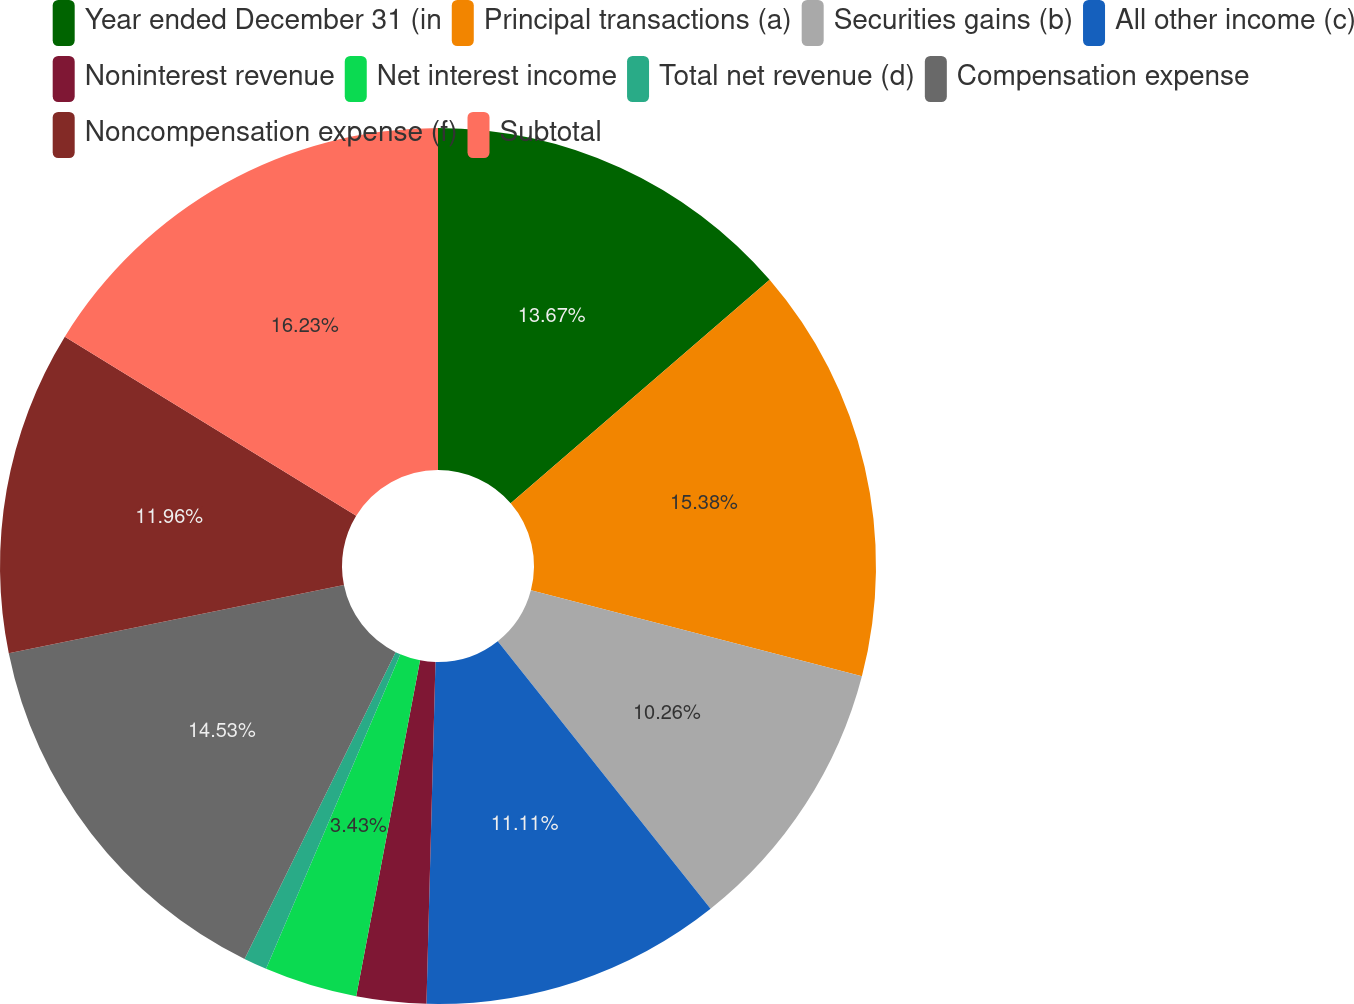Convert chart. <chart><loc_0><loc_0><loc_500><loc_500><pie_chart><fcel>Year ended December 31 (in<fcel>Principal transactions (a)<fcel>Securities gains (b)<fcel>All other income (c)<fcel>Noninterest revenue<fcel>Net interest income<fcel>Total net revenue (d)<fcel>Compensation expense<fcel>Noncompensation expense (f)<fcel>Subtotal<nl><fcel>13.67%<fcel>15.38%<fcel>10.26%<fcel>11.11%<fcel>2.57%<fcel>3.43%<fcel>0.86%<fcel>14.53%<fcel>11.96%<fcel>16.23%<nl></chart> 